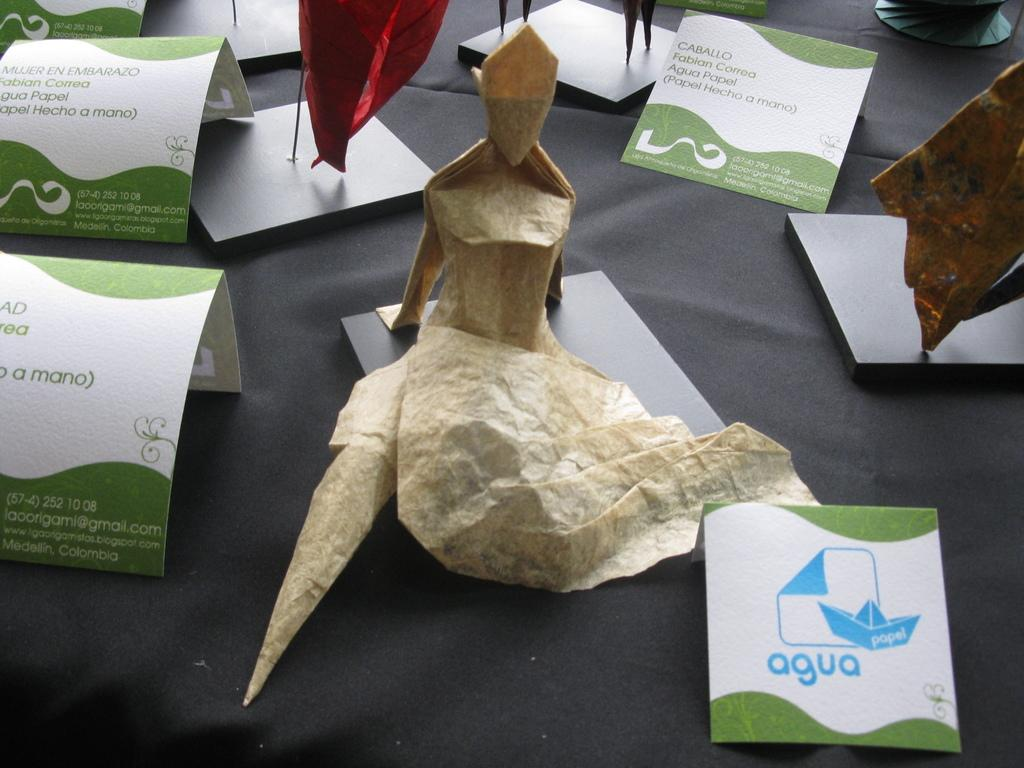What type of objects can be seen in the image? Papers and paper arts are visible in the image. What is the background or surface on which the papers and paper arts are placed? The papers and paper arts are on a grey color sheet. How many baseballs are visible in the image? There are no baseballs present in the image. What type of coil is used in the paper arts in the image? There is no mention of a coil in the image or the paper arts. 